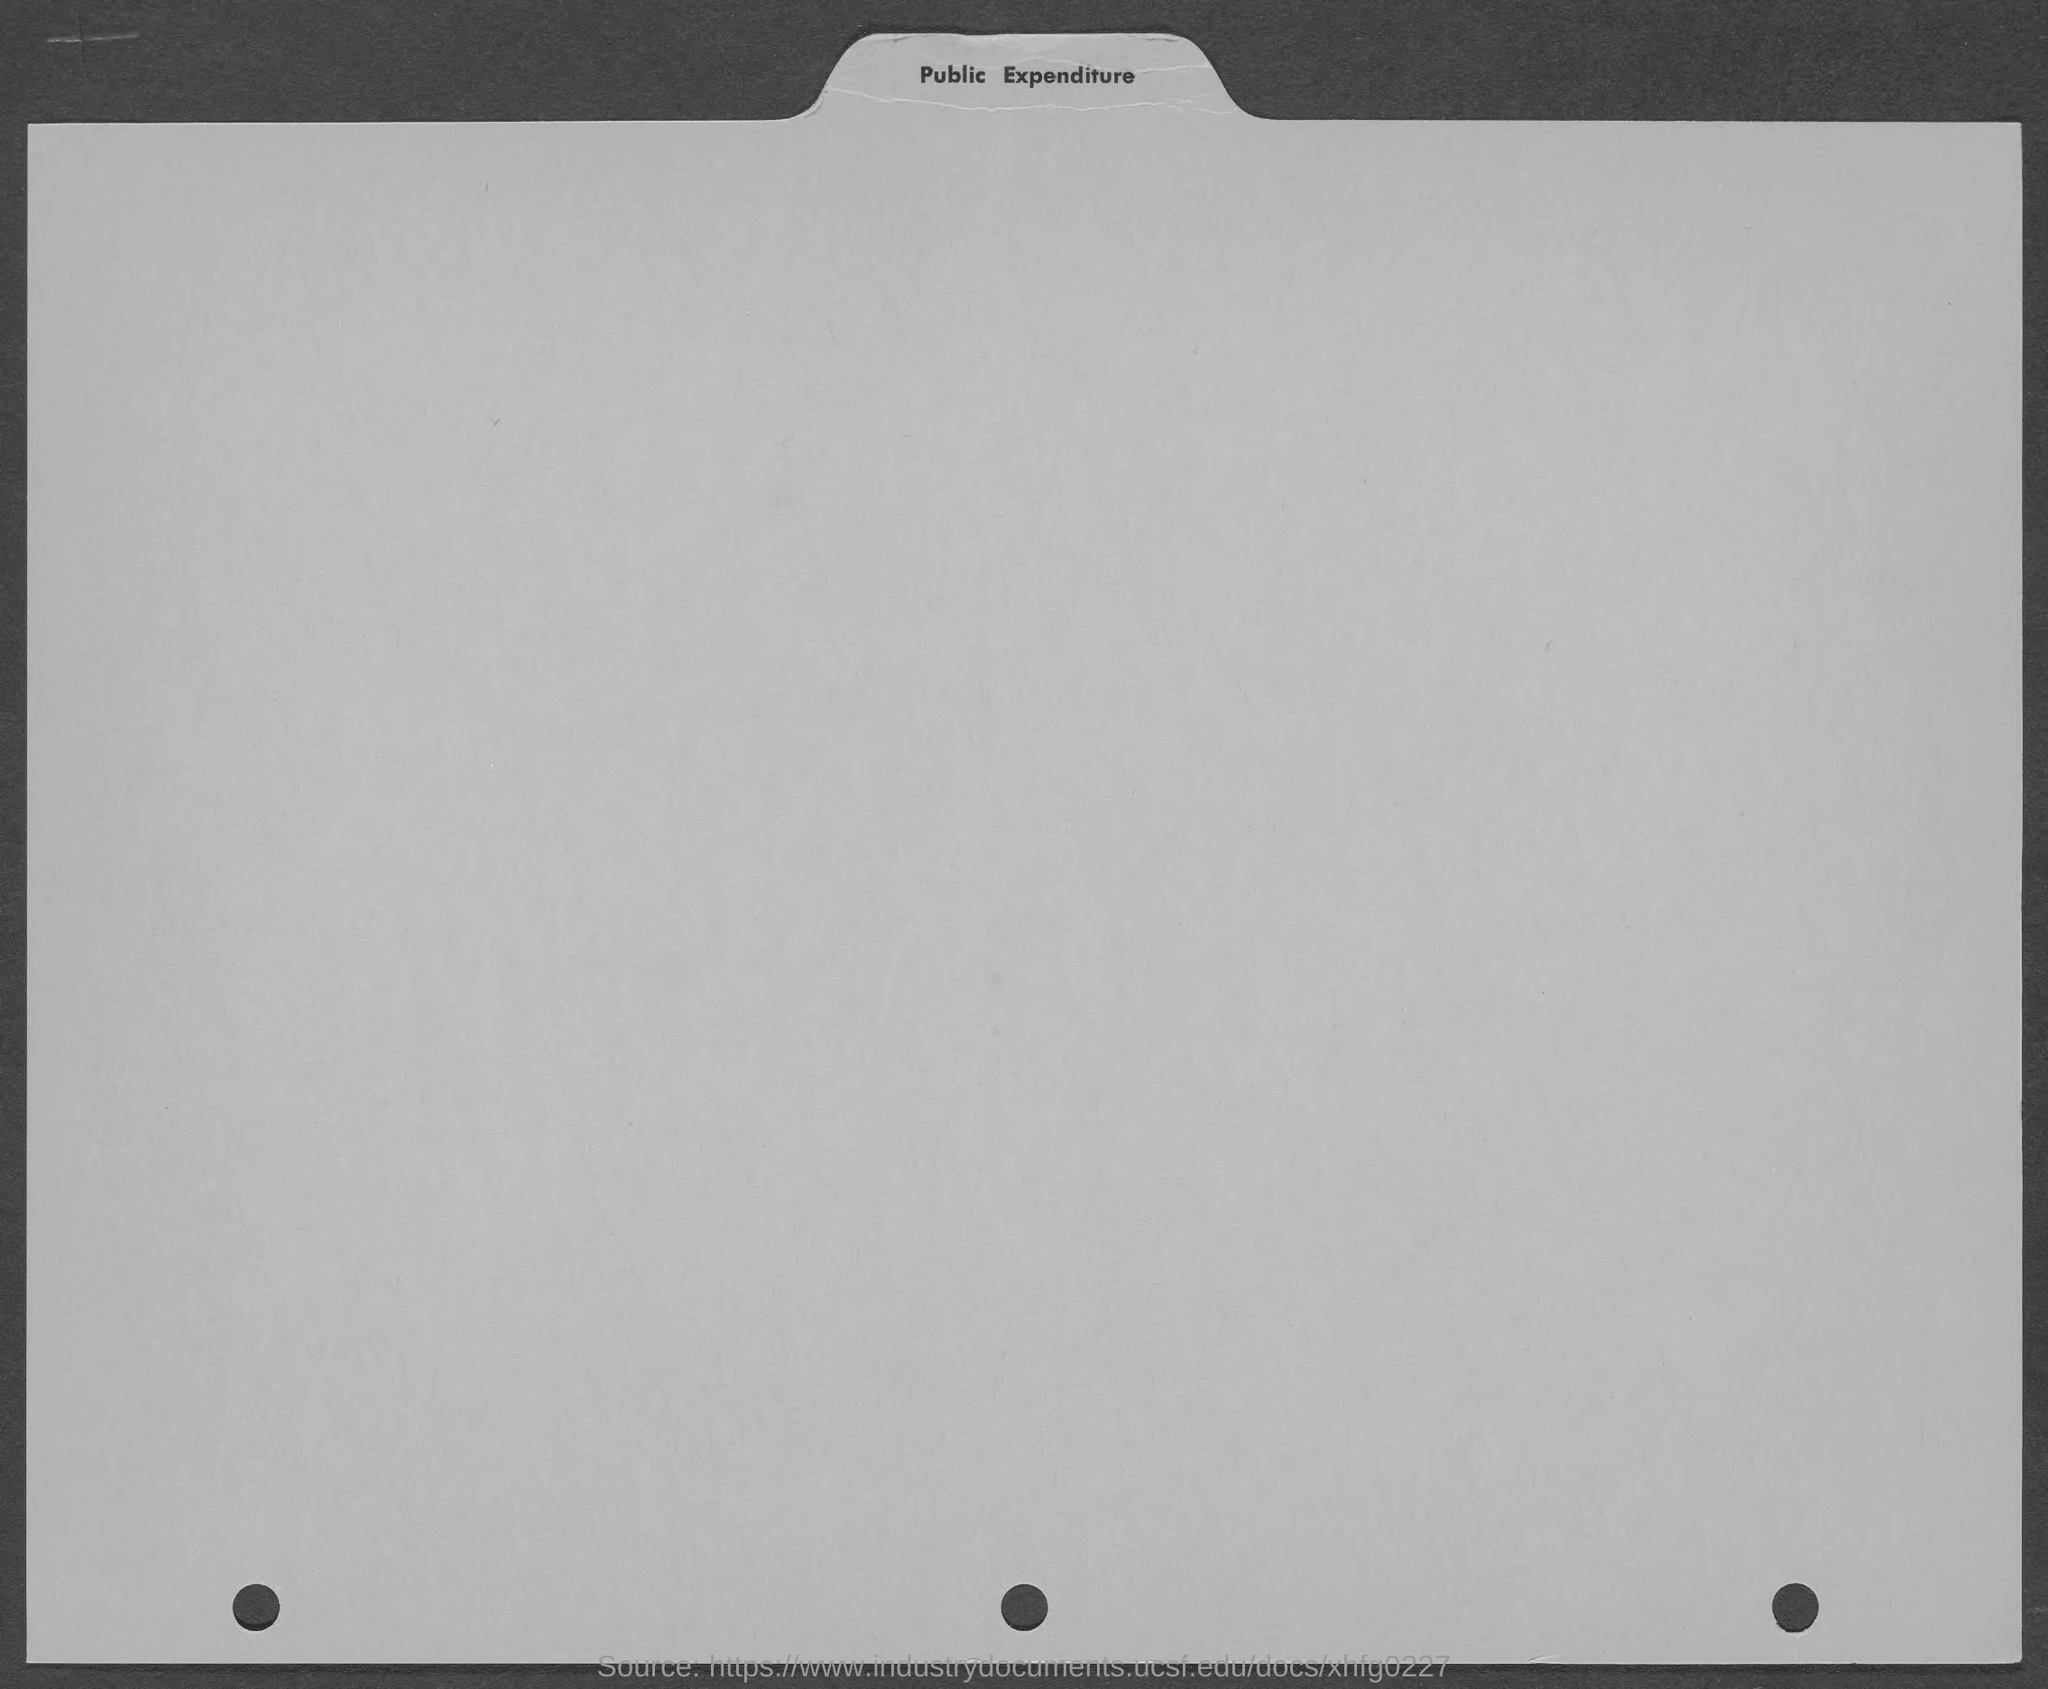Specify some key components in this picture. The heading of the page is "Public Expenditure. 